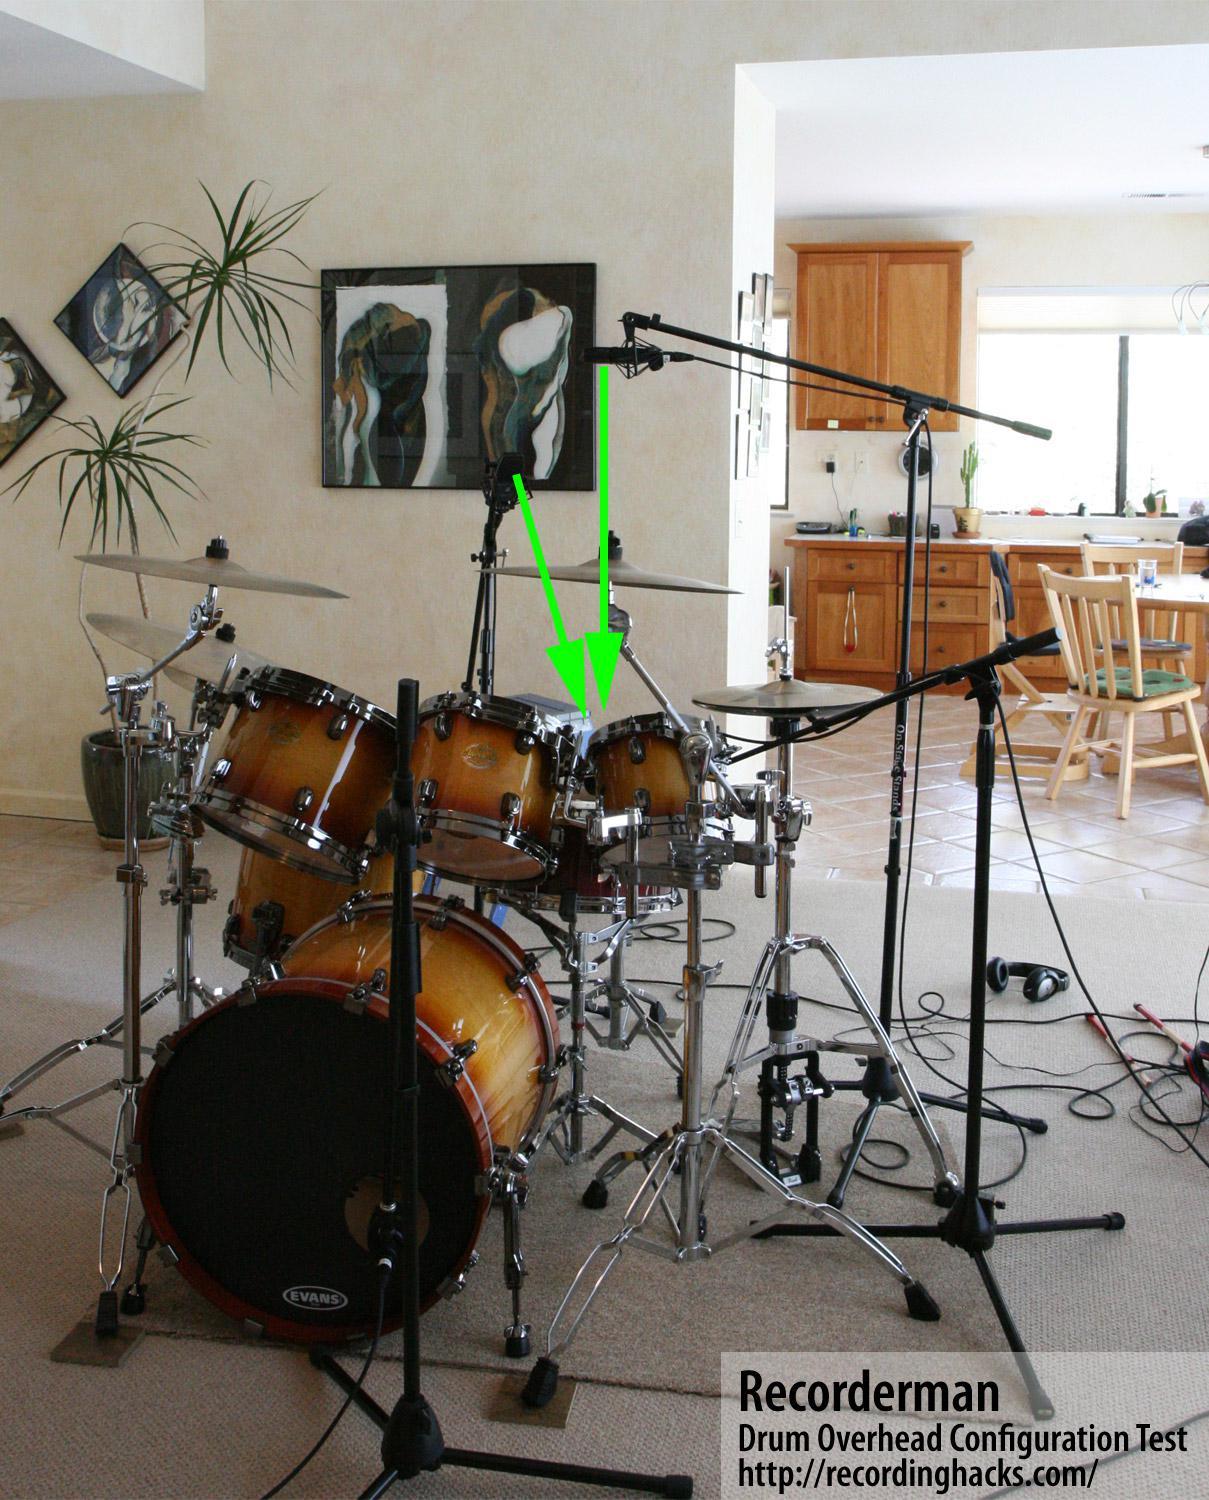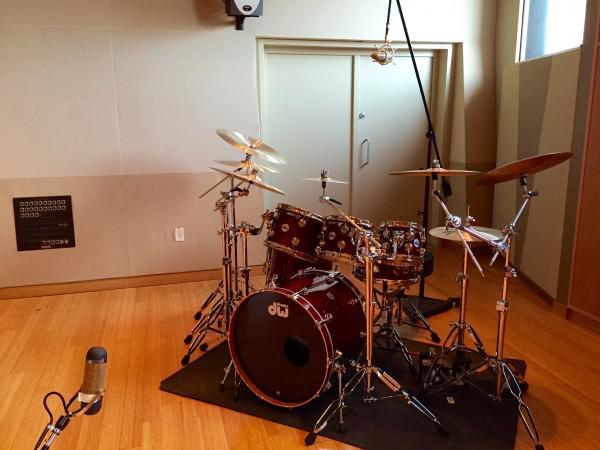The first image is the image on the left, the second image is the image on the right. Examine the images to the left and right. Is the description "There is a kick drum with white skin." accurate? Answer yes or no. No. 